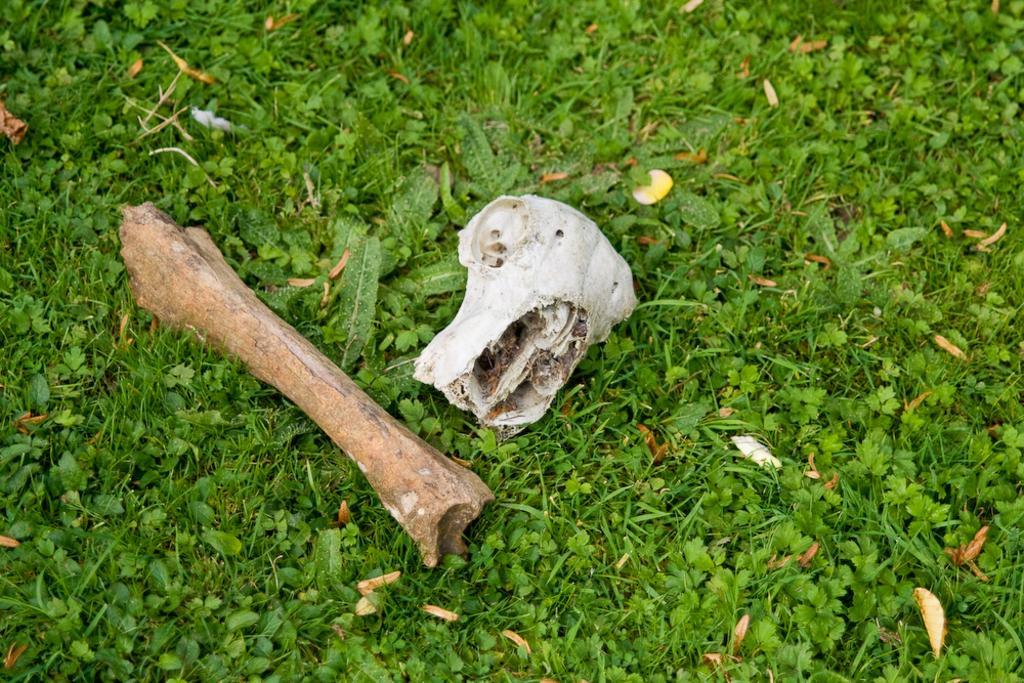Describe this image in one or two sentences. This image is taken outdoors. At the bottom of the image there is a ground with grass on it. In the middle of the image there are two bones on the ground. 